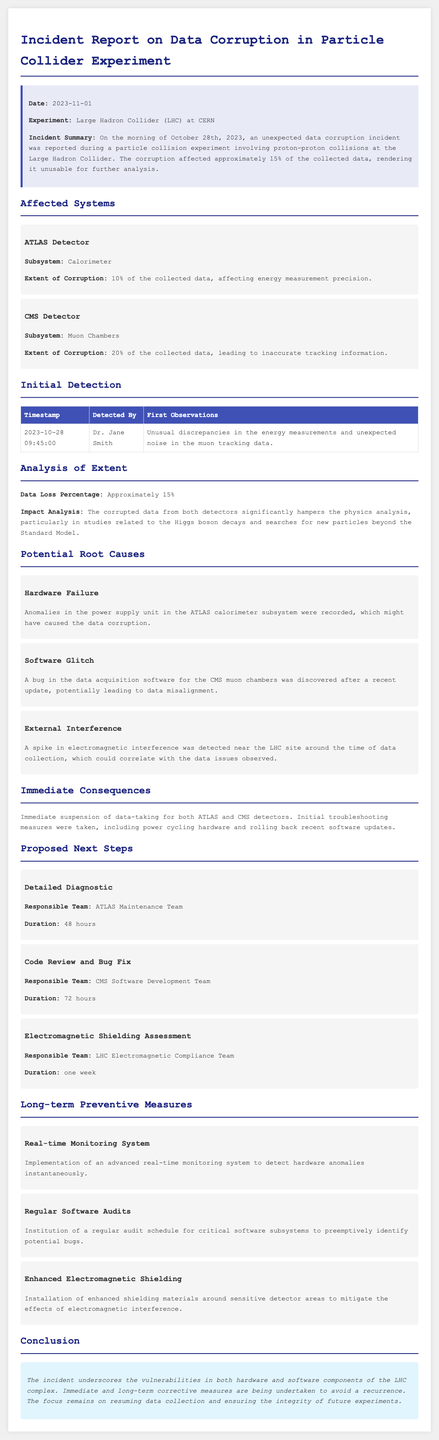what date did the incident occur? The incident summary states that the data corruption occurred on the morning of October 28th, 2023.
Answer: October 28th, 2023 how much data was affected in the ATLAS detector? The extent of corruption in the ATLAS detector's calorimeter subsystem is 10% of the collected data.
Answer: 10% who detected the issue first? The initial detection of the issue was made by Dr. Jane Smith, as mentioned in the initial detection table.
Answer: Dr. Jane Smith what percentage of the collected data was corrupted overall? The analysis of extent indicates that approximately 15% of the collected data was lost due to corruption.
Answer: 15% what is one of the proposed next steps? The report outlines several next steps; one example is the "Detailed Diagnostic" by the ATLAS Maintenance Team.
Answer: Detailed Diagnostic what potential root cause involves a recent update? The document mentions that a bug in the data acquisition software for the CMS muon chambers was discovered after a recent update.
Answer: Software Glitch what long-term preventive measure involves monitoring? The document suggests implementing a "Real-time Monitoring System" to detect hardware anomalies instantaneously as a preventive measure.
Answer: Real-time Monitoring System what immediate consequence occurred after the incident? The report states that there was an immediate suspension of data-taking for both the ATLAS and CMS detectors.
Answer: Suspension of data-taking what is the duration for the electromagnetic shielding assessment? The electromagnetic shielding assessment proposed is scheduled to take one week, as stated in the proposed next steps.
Answer: one week 